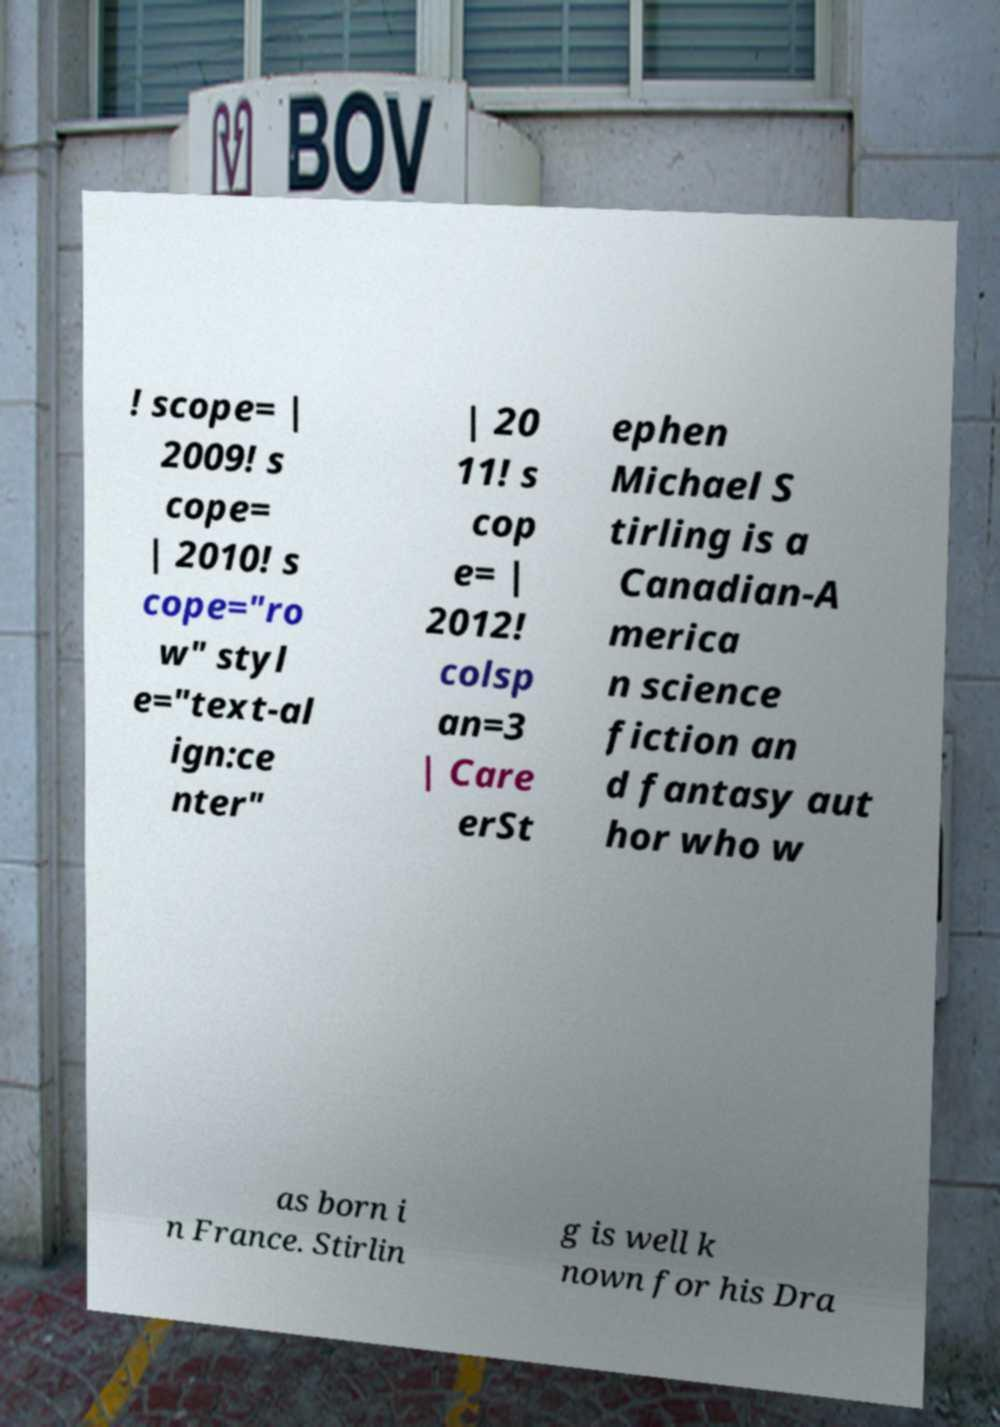For documentation purposes, I need the text within this image transcribed. Could you provide that? ! scope= | 2009! s cope= | 2010! s cope="ro w" styl e="text-al ign:ce nter" | 20 11! s cop e= | 2012! colsp an=3 | Care erSt ephen Michael S tirling is a Canadian-A merica n science fiction an d fantasy aut hor who w as born i n France. Stirlin g is well k nown for his Dra 